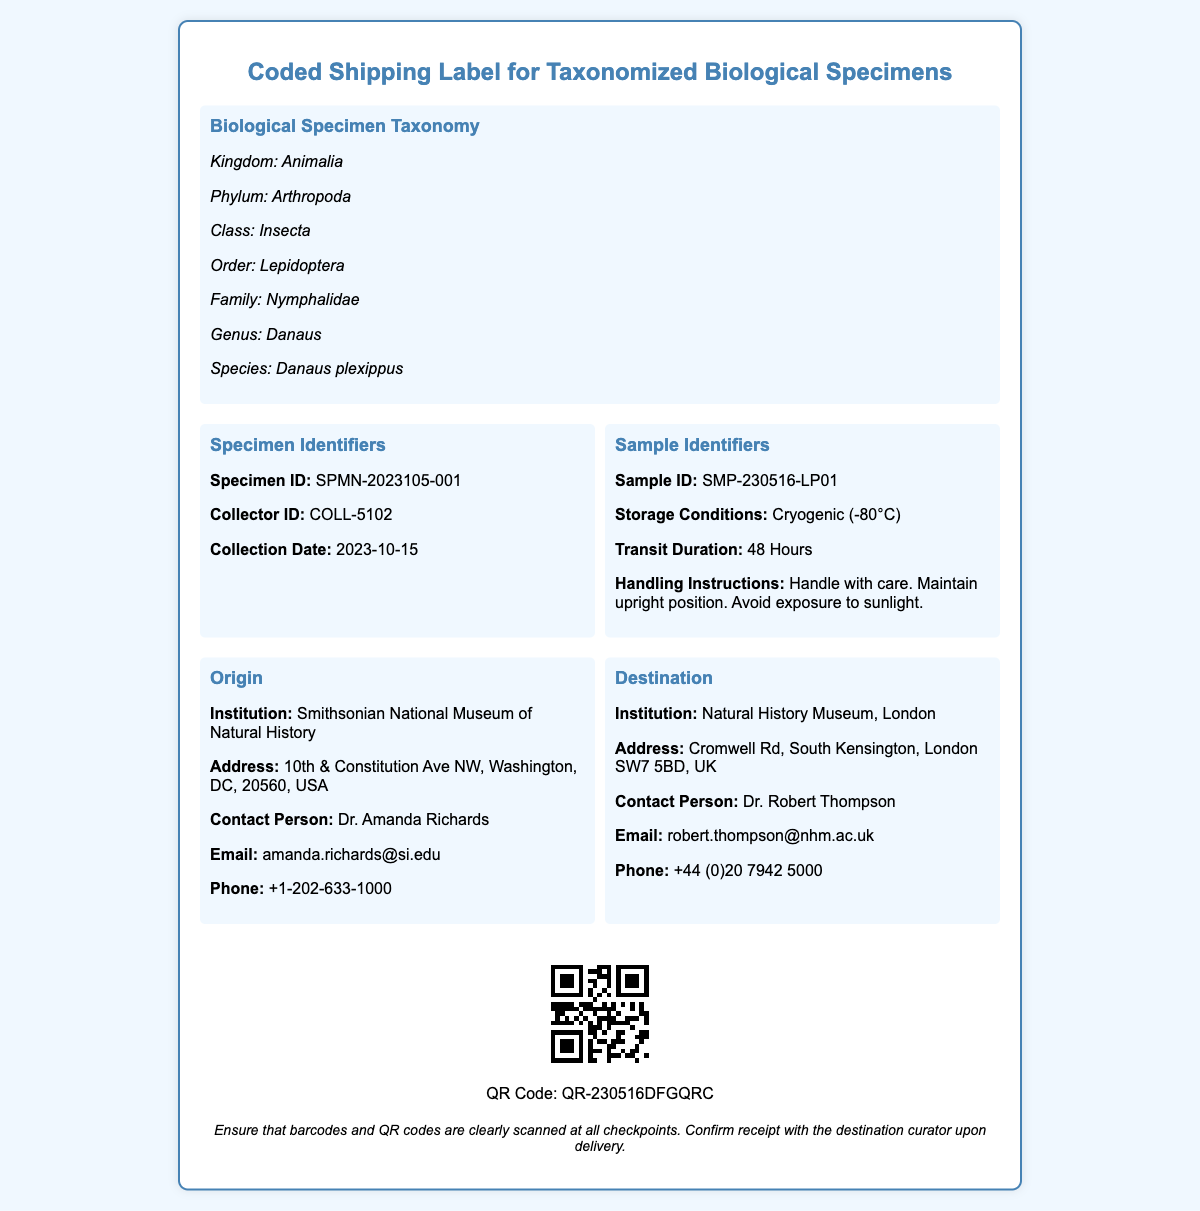What is the specimen ID? The specimen ID is listed in the document as a specific identifier for the biological specimen.
Answer: SPMN-2023105-001 Who is the contact person at the origin institution? The contact person is provided in the Origin section for the Smithsonian National Museum of Natural History.
Answer: Dr. Amanda Richards What are the storage conditions for the sample? The storage conditions detail how the specimen should be stored during transit.
Answer: Cryogenic (-80°C) Where is the destination institution located? The address of the destination institution is included in the document.
Answer: Cromwell Rd, South Kensington, London SW7 5BD, UK What is the collection date of the specimen? The collection date is specified in the Specimen Identifiers section of the document.
Answer: 2023-10-15 What QR code is associated with the specimen? The QR code is generated for specific tracking purposes and is included in the shipping label.
Answer: QR-230516DFGQRC What handling instructions are provided for the sample? The handling instructions help ensure the sample is treated correctly during transit.
Answer: Handle with care. Maintain upright position. Avoid exposure to sunlight Which taxonomic family does the specimen belong to? The taxonomic family is part of the biological classification provided in the document.
Answer: Nymphalidae What is the transit duration specified for the sample? The transit duration indicates how long the specimen will be in transit, which is crucial for the receiving party.
Answer: 48 Hours 